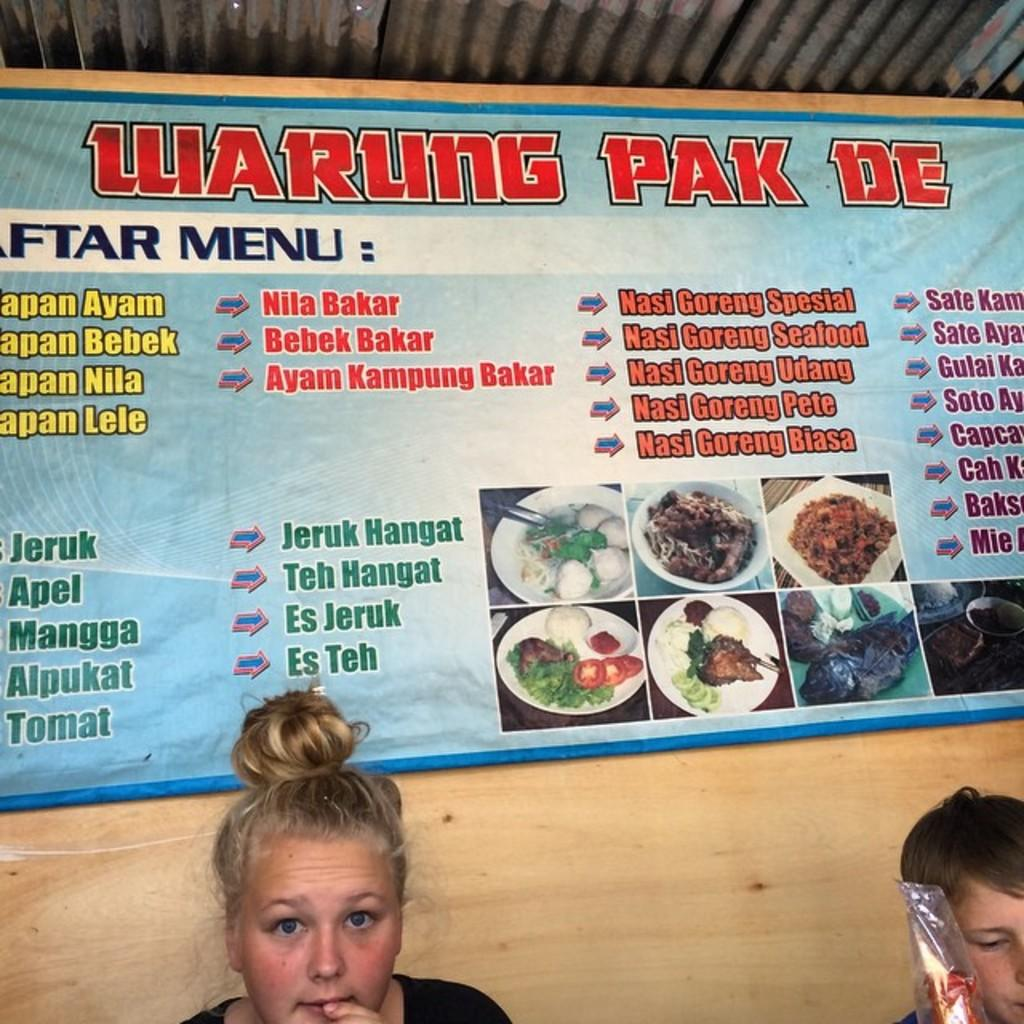What is on the wall in the image? There is a menu banner on the wall in the image. What is the material of the wall above the menu banner? The wall has iron sheets above the menu banner. Who can be seen in the image besides the menu banner? There is a blond-haired woman and a boy visible in the image. What type of connection is visible between the blond-haired woman and the boy in the image? There is no visible connection between the blond-haired woman and the boy in the image. What type of apparel is the blond-haired woman wearing in the image? The provided facts do not mention the apparel of the blond-haired woman in the image. 